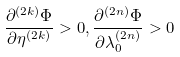<formula> <loc_0><loc_0><loc_500><loc_500>\frac { \partial ^ { ( 2 k ) } \Phi } { \partial \eta ^ { ( 2 k ) } } > 0 , \frac { \partial ^ { ( 2 n ) } \Phi } { \partial \lambda _ { 0 } ^ { ( 2 n ) } } > 0</formula> 